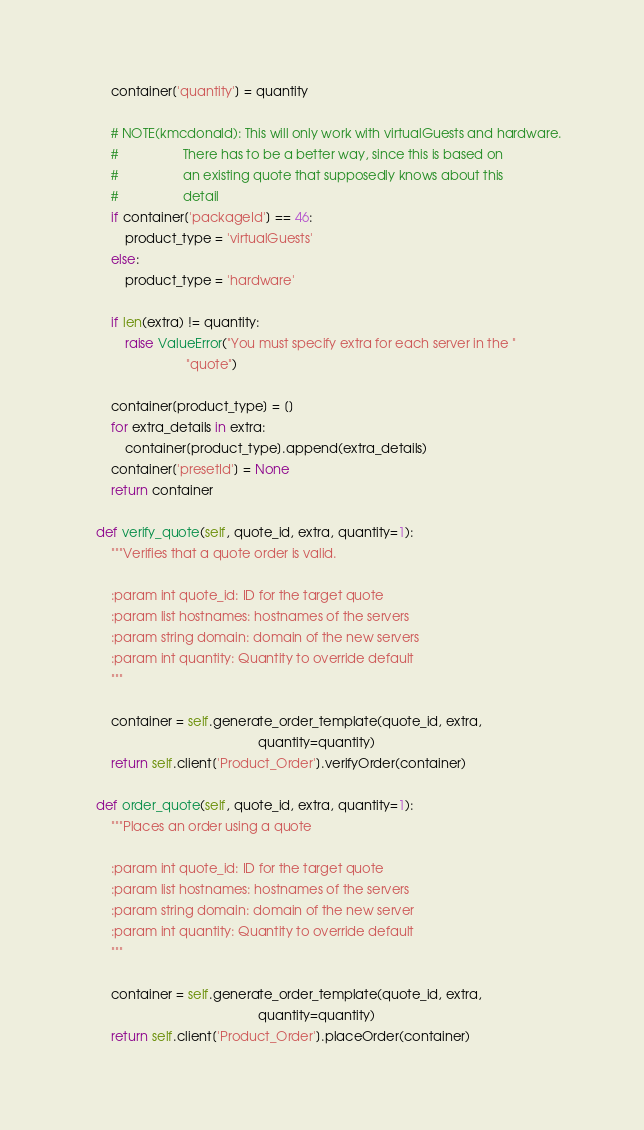Convert code to text. <code><loc_0><loc_0><loc_500><loc_500><_Python_>        container['quantity'] = quantity

        # NOTE(kmcdonald): This will only work with virtualGuests and hardware.
        #                  There has to be a better way, since this is based on
        #                  an existing quote that supposedly knows about this
        #                  detail
        if container['packageId'] == 46:
            product_type = 'virtualGuests'
        else:
            product_type = 'hardware'

        if len(extra) != quantity:
            raise ValueError("You must specify extra for each server in the "
                             "quote")

        container[product_type] = []
        for extra_details in extra:
            container[product_type].append(extra_details)
        container['presetId'] = None
        return container

    def verify_quote(self, quote_id, extra, quantity=1):
        """Verifies that a quote order is valid.

        :param int quote_id: ID for the target quote
        :param list hostnames: hostnames of the servers
        :param string domain: domain of the new servers
        :param int quantity: Quantity to override default
        """

        container = self.generate_order_template(quote_id, extra,
                                                 quantity=quantity)
        return self.client['Product_Order'].verifyOrder(container)

    def order_quote(self, quote_id, extra, quantity=1):
        """Places an order using a quote

        :param int quote_id: ID for the target quote
        :param list hostnames: hostnames of the servers
        :param string domain: domain of the new server
        :param int quantity: Quantity to override default
        """

        container = self.generate_order_template(quote_id, extra,
                                                 quantity=quantity)
        return self.client['Product_Order'].placeOrder(container)
</code> 